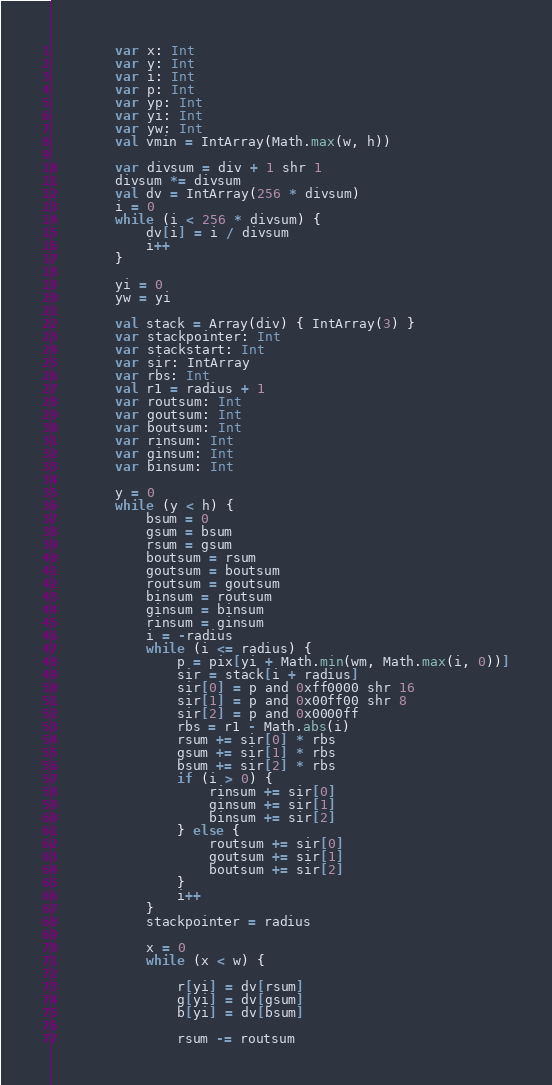<code> <loc_0><loc_0><loc_500><loc_500><_Kotlin_>        var x: Int
        var y: Int
        var i: Int
        var p: Int
        var yp: Int
        var yi: Int
        var yw: Int
        val vmin = IntArray(Math.max(w, h))

        var divsum = div + 1 shr 1
        divsum *= divsum
        val dv = IntArray(256 * divsum)
        i = 0
        while (i < 256 * divsum) {
            dv[i] = i / divsum
            i++
        }

        yi = 0
        yw = yi

        val stack = Array(div) { IntArray(3) }
        var stackpointer: Int
        var stackstart: Int
        var sir: IntArray
        var rbs: Int
        val r1 = radius + 1
        var routsum: Int
        var goutsum: Int
        var boutsum: Int
        var rinsum: Int
        var ginsum: Int
        var binsum: Int

        y = 0
        while (y < h) {
            bsum = 0
            gsum = bsum
            rsum = gsum
            boutsum = rsum
            goutsum = boutsum
            routsum = goutsum
            binsum = routsum
            ginsum = binsum
            rinsum = ginsum
            i = -radius
            while (i <= radius) {
                p = pix[yi + Math.min(wm, Math.max(i, 0))]
                sir = stack[i + radius]
                sir[0] = p and 0xff0000 shr 16
                sir[1] = p and 0x00ff00 shr 8
                sir[2] = p and 0x0000ff
                rbs = r1 - Math.abs(i)
                rsum += sir[0] * rbs
                gsum += sir[1] * rbs
                bsum += sir[2] * rbs
                if (i > 0) {
                    rinsum += sir[0]
                    ginsum += sir[1]
                    binsum += sir[2]
                } else {
                    routsum += sir[0]
                    goutsum += sir[1]
                    boutsum += sir[2]
                }
                i++
            }
            stackpointer = radius

            x = 0
            while (x < w) {

                r[yi] = dv[rsum]
                g[yi] = dv[gsum]
                b[yi] = dv[bsum]

                rsum -= routsum</code> 